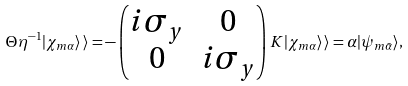<formula> <loc_0><loc_0><loc_500><loc_500>\Theta \eta ^ { - 1 } | \chi _ { m \alpha } \rangle \, \rangle = - \begin{pmatrix} i \sigma _ { y } & 0 \\ 0 & i \sigma _ { y } \end{pmatrix} K | \chi _ { m \alpha } \rangle \, \rangle = { \alpha } | \psi _ { m \bar { \alpha } } \rangle ,</formula> 